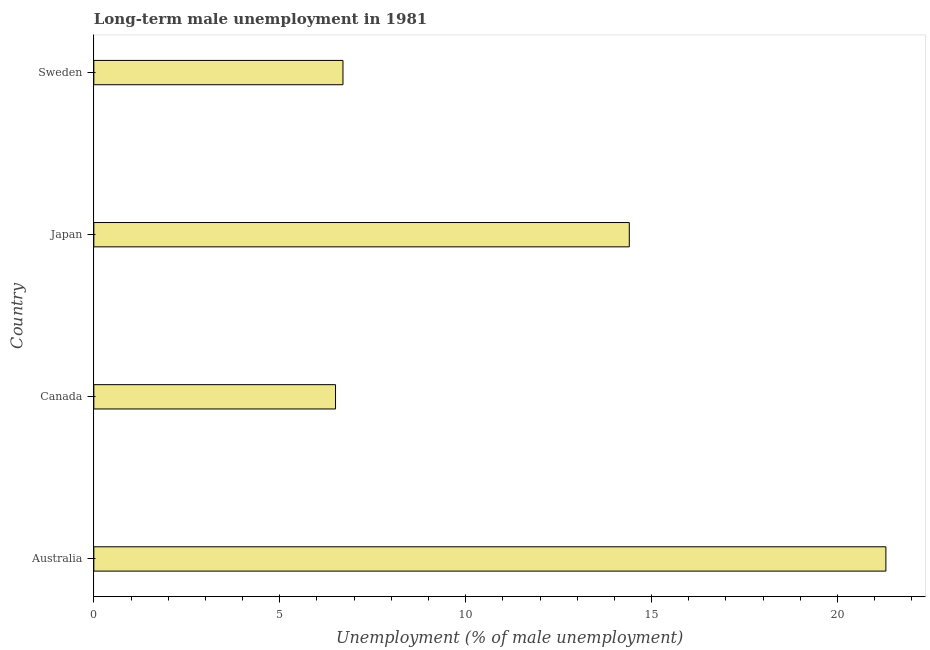Does the graph contain grids?
Make the answer very short. No. What is the title of the graph?
Ensure brevity in your answer.  Long-term male unemployment in 1981. What is the label or title of the X-axis?
Give a very brief answer. Unemployment (% of male unemployment). What is the long-term male unemployment in Sweden?
Provide a succinct answer. 6.7. Across all countries, what is the maximum long-term male unemployment?
Ensure brevity in your answer.  21.3. What is the sum of the long-term male unemployment?
Your response must be concise. 48.9. What is the average long-term male unemployment per country?
Ensure brevity in your answer.  12.22. What is the median long-term male unemployment?
Make the answer very short. 10.55. What is the ratio of the long-term male unemployment in Australia to that in Canada?
Offer a terse response. 3.28. Is the long-term male unemployment in Australia less than that in Japan?
Your answer should be very brief. No. What is the difference between the highest and the second highest long-term male unemployment?
Provide a short and direct response. 6.9. In how many countries, is the long-term male unemployment greater than the average long-term male unemployment taken over all countries?
Provide a succinct answer. 2. What is the difference between two consecutive major ticks on the X-axis?
Offer a terse response. 5. What is the Unemployment (% of male unemployment) of Australia?
Provide a succinct answer. 21.3. What is the Unemployment (% of male unemployment) of Japan?
Your answer should be compact. 14.4. What is the Unemployment (% of male unemployment) in Sweden?
Make the answer very short. 6.7. What is the difference between the Unemployment (% of male unemployment) in Australia and Sweden?
Make the answer very short. 14.6. What is the difference between the Unemployment (% of male unemployment) in Canada and Japan?
Provide a short and direct response. -7.9. What is the difference between the Unemployment (% of male unemployment) in Canada and Sweden?
Your answer should be compact. -0.2. What is the ratio of the Unemployment (% of male unemployment) in Australia to that in Canada?
Your answer should be very brief. 3.28. What is the ratio of the Unemployment (% of male unemployment) in Australia to that in Japan?
Make the answer very short. 1.48. What is the ratio of the Unemployment (% of male unemployment) in Australia to that in Sweden?
Make the answer very short. 3.18. What is the ratio of the Unemployment (% of male unemployment) in Canada to that in Japan?
Give a very brief answer. 0.45. What is the ratio of the Unemployment (% of male unemployment) in Japan to that in Sweden?
Offer a terse response. 2.15. 